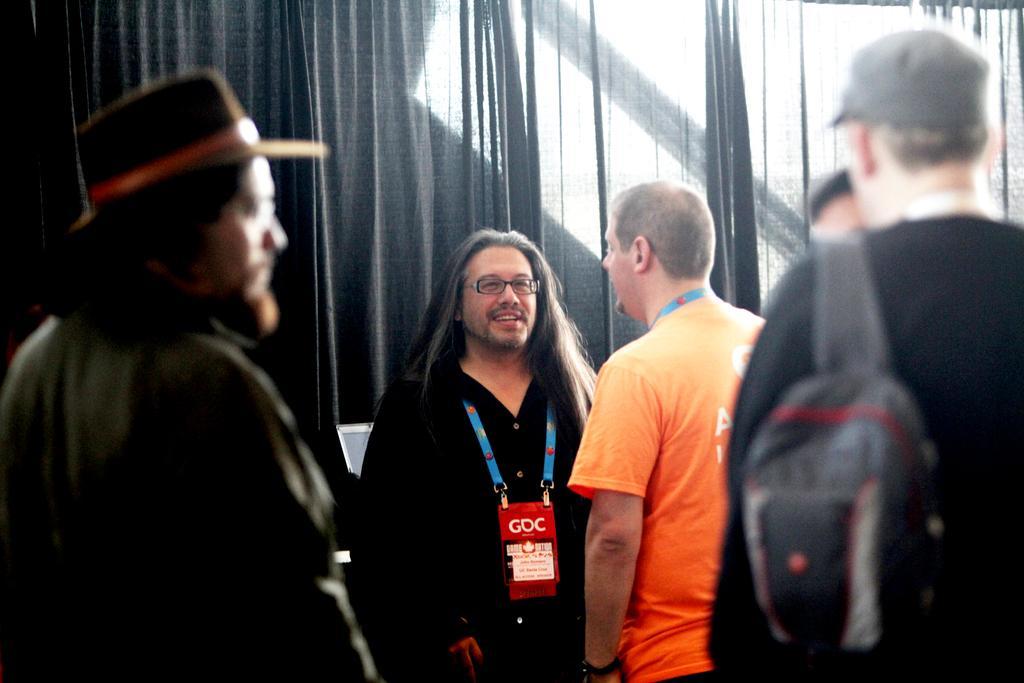Can you describe this image briefly? In this image there are group of persons standing. The man in the center is wearing a black colour dress and smiling. On the right side in the front the man is wearing a bag and a grey colour hat. On the left side the man is wearing a black colour jacket and black colour hat. In the background there is a curtain. 